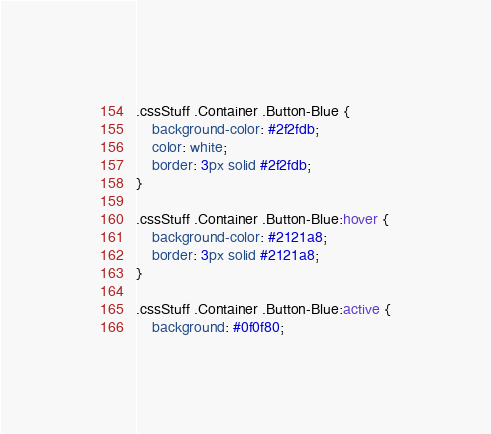<code> <loc_0><loc_0><loc_500><loc_500><_CSS_>.cssStuff .Container .Button-Blue {
    background-color: #2f2fdb;
    color: white;
    border: 3px solid #2f2fdb;
}

.cssStuff .Container .Button-Blue:hover {
    background-color: #2121a8;
    border: 3px solid #2121a8;
}

.cssStuff .Container .Button-Blue:active {
    background: #0f0f80;</code> 